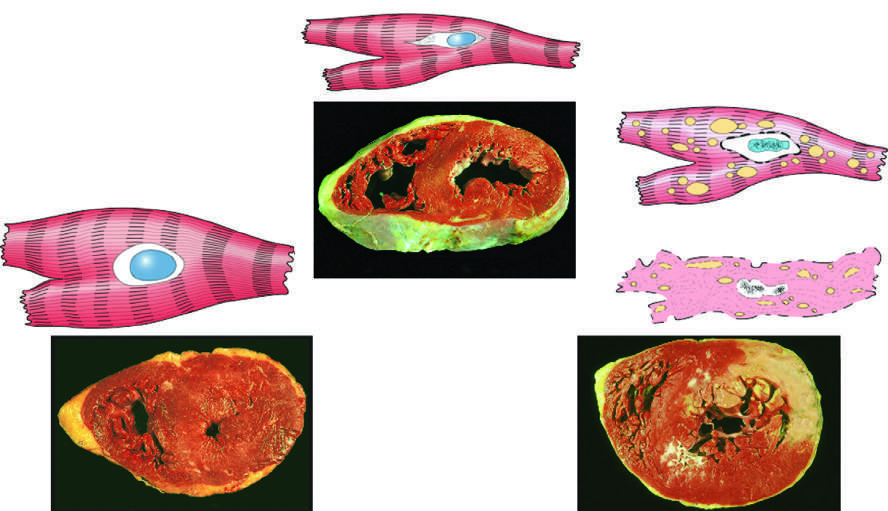does reversibly injured myocardium show functional effects without any gross or light microscopic changes, or reversible changes such as cellular swelling and fatty change?
Answer the question using a single word or phrase. Yes 